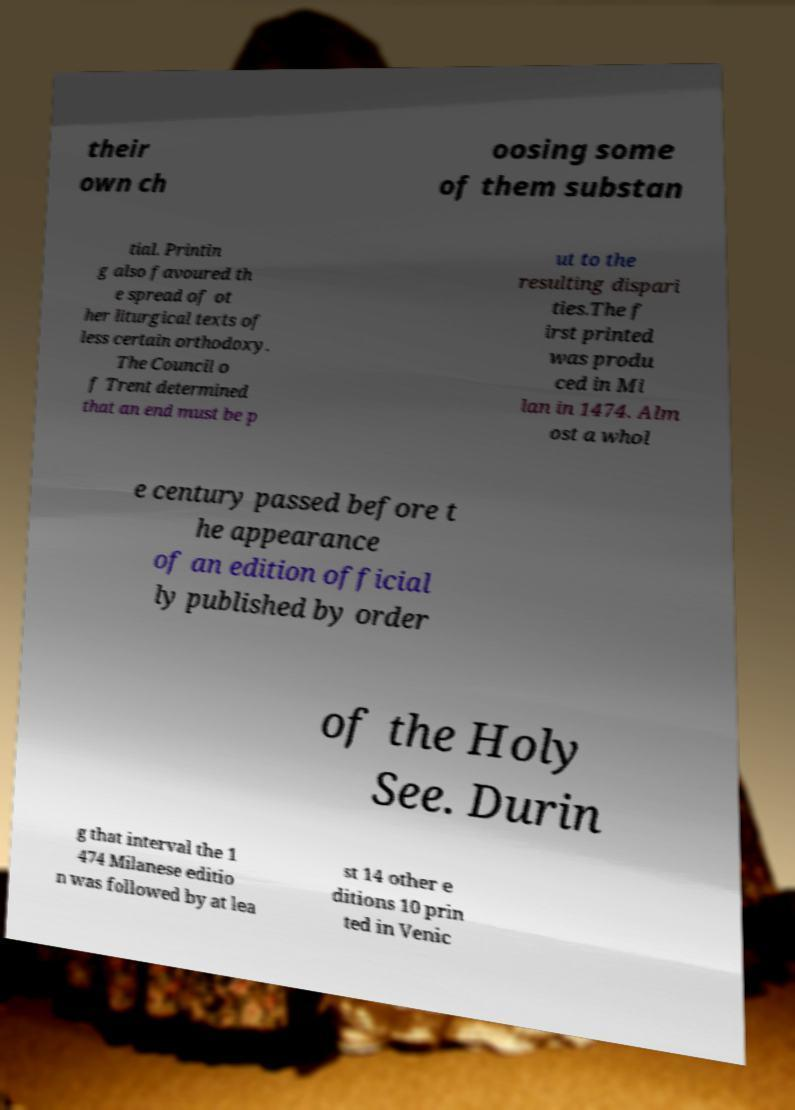Please read and relay the text visible in this image. What does it say? their own ch oosing some of them substan tial. Printin g also favoured th e spread of ot her liturgical texts of less certain orthodoxy. The Council o f Trent determined that an end must be p ut to the resulting dispari ties.The f irst printed was produ ced in Mi lan in 1474. Alm ost a whol e century passed before t he appearance of an edition official ly published by order of the Holy See. Durin g that interval the 1 474 Milanese editio n was followed by at lea st 14 other e ditions 10 prin ted in Venic 